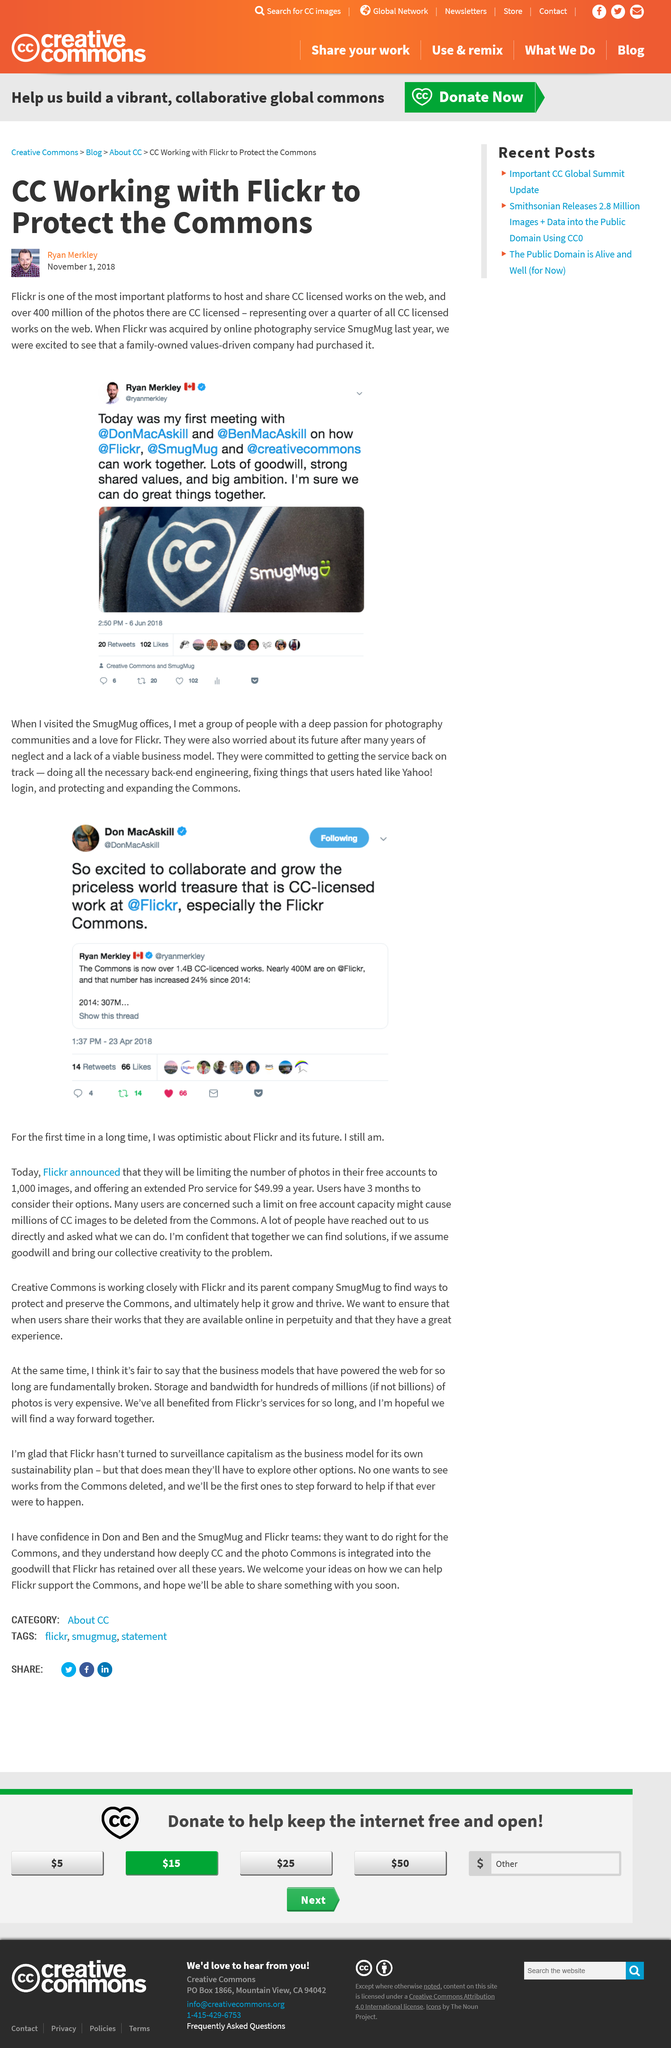Highlight a few significant elements in this photo. Flickr's photos that are licensed under Creative Commons (CC) make up over 400 million of its total photo collection. Ryan Merkley met with Don MacAskill and Ben MacAskill to discuss the possibility of collaboration between Flickr, SmugMug, and Creative Commons. SmugMug acquired Flickr, a popular online photography service. 